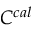<formula> <loc_0><loc_0><loc_500><loc_500>C ^ { c a l }</formula> 